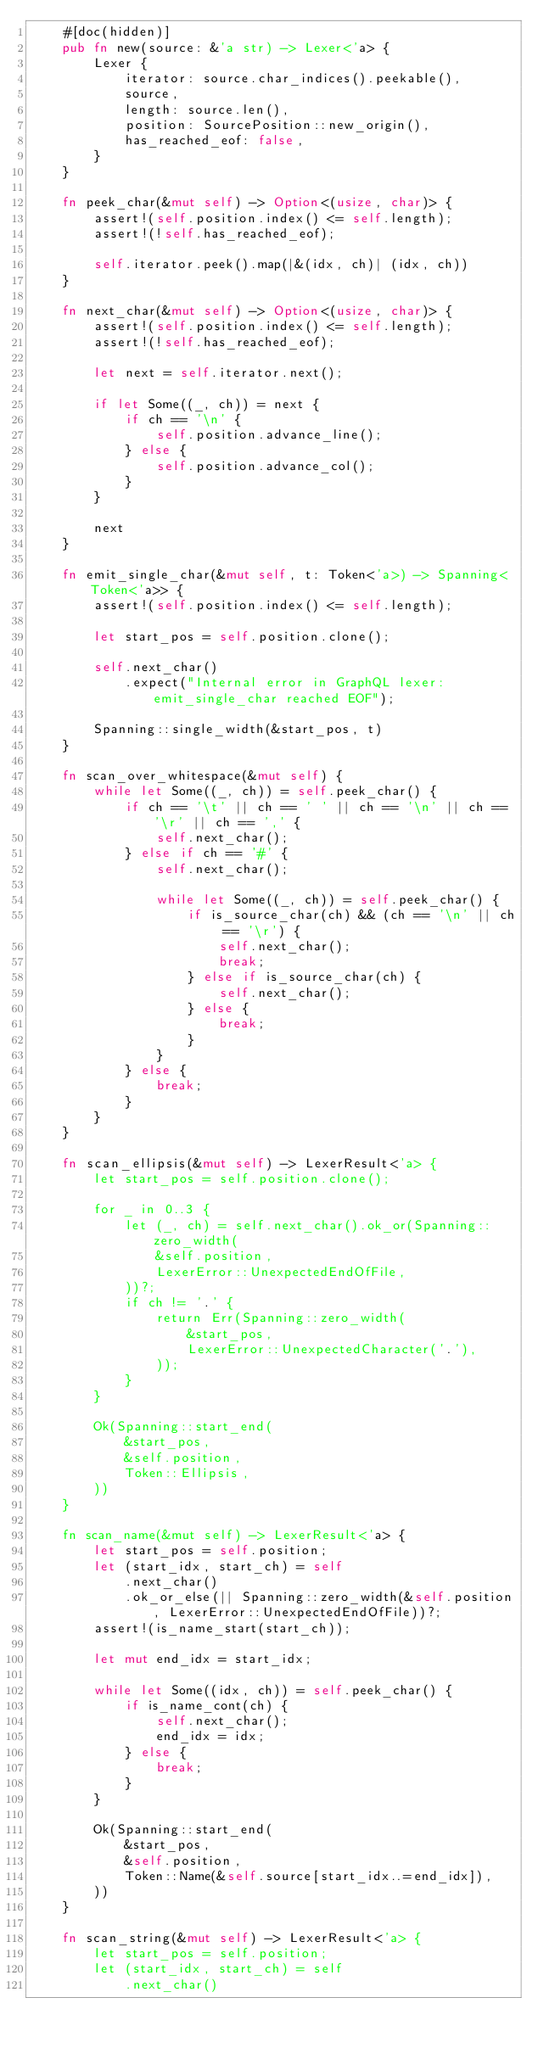Convert code to text. <code><loc_0><loc_0><loc_500><loc_500><_Rust_>    #[doc(hidden)]
    pub fn new(source: &'a str) -> Lexer<'a> {
        Lexer {
            iterator: source.char_indices().peekable(),
            source,
            length: source.len(),
            position: SourcePosition::new_origin(),
            has_reached_eof: false,
        }
    }

    fn peek_char(&mut self) -> Option<(usize, char)> {
        assert!(self.position.index() <= self.length);
        assert!(!self.has_reached_eof);

        self.iterator.peek().map(|&(idx, ch)| (idx, ch))
    }

    fn next_char(&mut self) -> Option<(usize, char)> {
        assert!(self.position.index() <= self.length);
        assert!(!self.has_reached_eof);

        let next = self.iterator.next();

        if let Some((_, ch)) = next {
            if ch == '\n' {
                self.position.advance_line();
            } else {
                self.position.advance_col();
            }
        }

        next
    }

    fn emit_single_char(&mut self, t: Token<'a>) -> Spanning<Token<'a>> {
        assert!(self.position.index() <= self.length);

        let start_pos = self.position.clone();

        self.next_char()
            .expect("Internal error in GraphQL lexer: emit_single_char reached EOF");

        Spanning::single_width(&start_pos, t)
    }

    fn scan_over_whitespace(&mut self) {
        while let Some((_, ch)) = self.peek_char() {
            if ch == '\t' || ch == ' ' || ch == '\n' || ch == '\r' || ch == ',' {
                self.next_char();
            } else if ch == '#' {
                self.next_char();

                while let Some((_, ch)) = self.peek_char() {
                    if is_source_char(ch) && (ch == '\n' || ch == '\r') {
                        self.next_char();
                        break;
                    } else if is_source_char(ch) {
                        self.next_char();
                    } else {
                        break;
                    }
                }
            } else {
                break;
            }
        }
    }

    fn scan_ellipsis(&mut self) -> LexerResult<'a> {
        let start_pos = self.position.clone();

        for _ in 0..3 {
            let (_, ch) = self.next_char().ok_or(Spanning::zero_width(
                &self.position,
                LexerError::UnexpectedEndOfFile,
            ))?;
            if ch != '.' {
                return Err(Spanning::zero_width(
                    &start_pos,
                    LexerError::UnexpectedCharacter('.'),
                ));
            }
        }

        Ok(Spanning::start_end(
            &start_pos,
            &self.position,
            Token::Ellipsis,
        ))
    }

    fn scan_name(&mut self) -> LexerResult<'a> {
        let start_pos = self.position;
        let (start_idx, start_ch) = self
            .next_char()
            .ok_or_else(|| Spanning::zero_width(&self.position, LexerError::UnexpectedEndOfFile))?;
        assert!(is_name_start(start_ch));

        let mut end_idx = start_idx;

        while let Some((idx, ch)) = self.peek_char() {
            if is_name_cont(ch) {
                self.next_char();
                end_idx = idx;
            } else {
                break;
            }
        }

        Ok(Spanning::start_end(
            &start_pos,
            &self.position,
            Token::Name(&self.source[start_idx..=end_idx]),
        ))
    }

    fn scan_string(&mut self) -> LexerResult<'a> {
        let start_pos = self.position;
        let (start_idx, start_ch) = self
            .next_char()</code> 